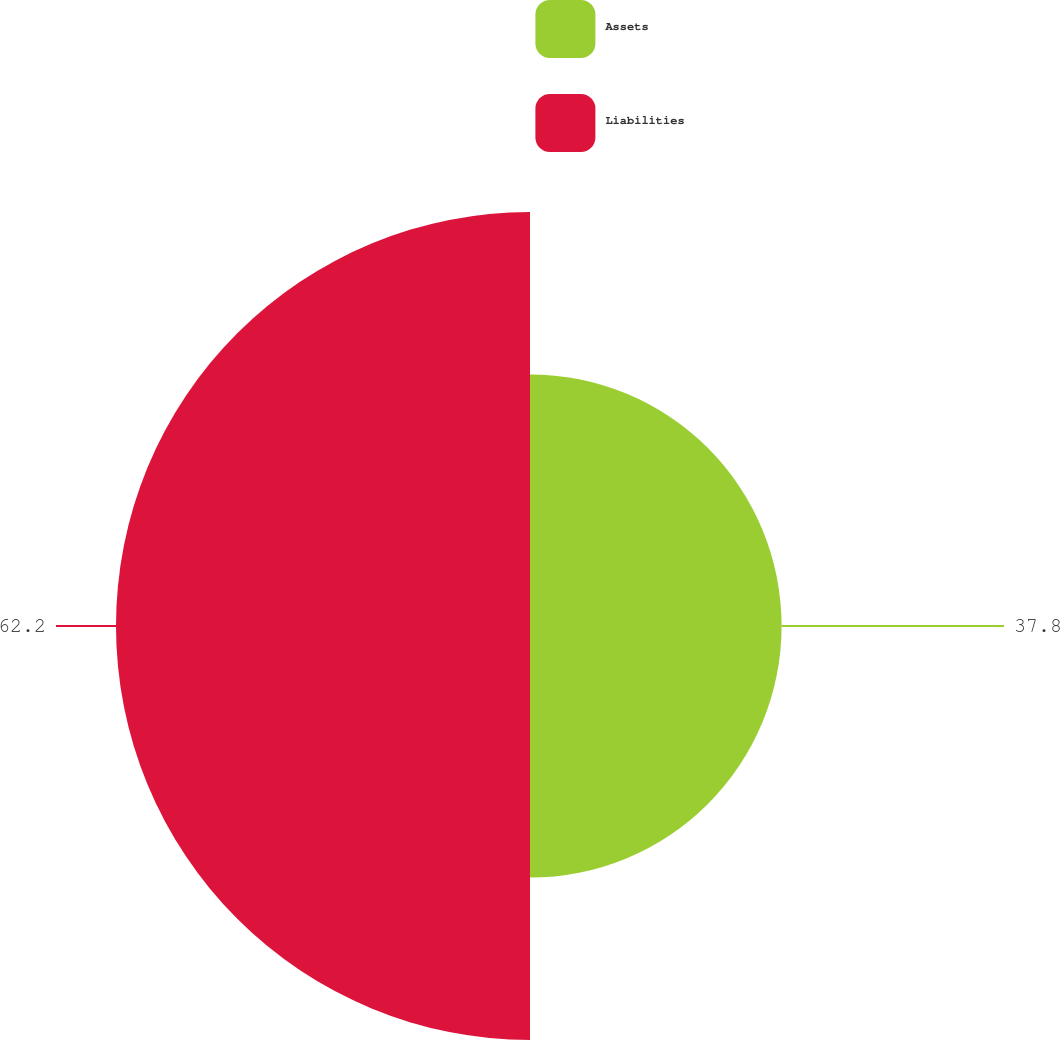<chart> <loc_0><loc_0><loc_500><loc_500><pie_chart><fcel>Assets<fcel>Liabilities<nl><fcel>37.8%<fcel>62.2%<nl></chart> 